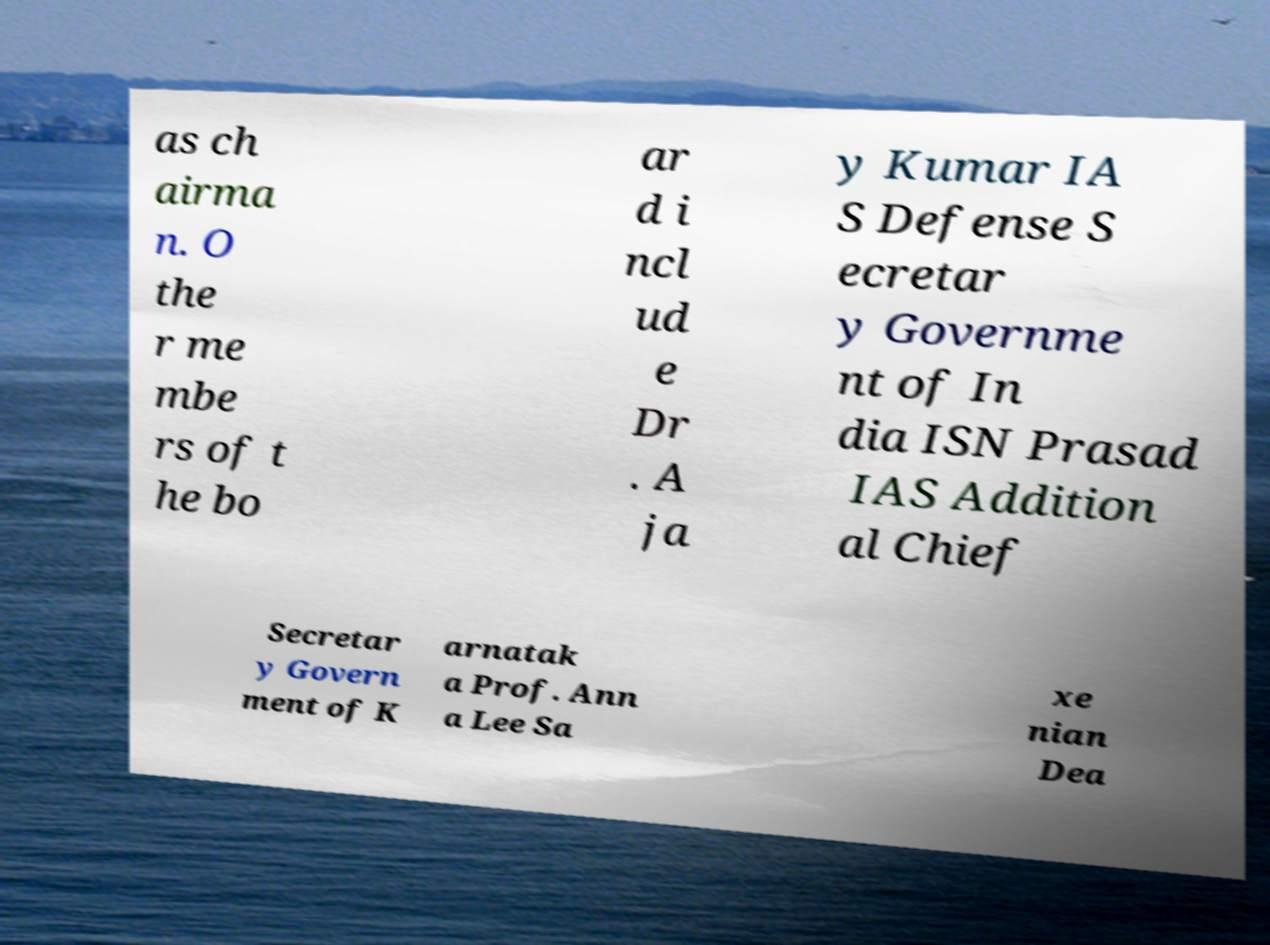For documentation purposes, I need the text within this image transcribed. Could you provide that? as ch airma n. O the r me mbe rs of t he bo ar d i ncl ud e Dr . A ja y Kumar IA S Defense S ecretar y Governme nt of In dia ISN Prasad IAS Addition al Chief Secretar y Govern ment of K arnatak a Prof. Ann a Lee Sa xe nian Dea 